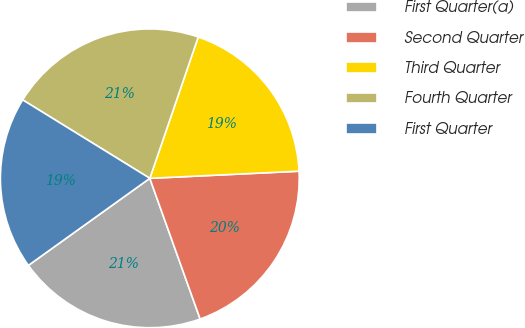Convert chart to OTSL. <chart><loc_0><loc_0><loc_500><loc_500><pie_chart><fcel>First Quarter(a)<fcel>Second Quarter<fcel>Third Quarter<fcel>Fourth Quarter<fcel>First Quarter<nl><fcel>20.57%<fcel>20.29%<fcel>18.99%<fcel>21.45%<fcel>18.7%<nl></chart> 